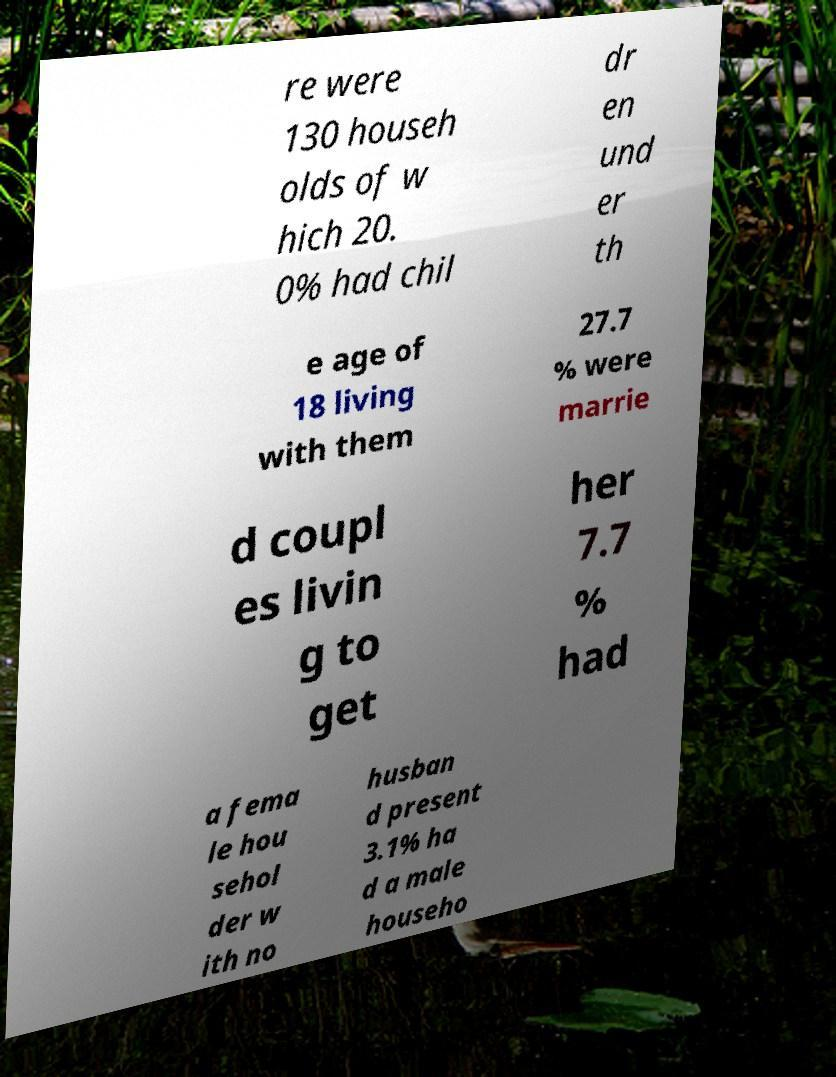Could you assist in decoding the text presented in this image and type it out clearly? re were 130 househ olds of w hich 20. 0% had chil dr en und er th e age of 18 living with them 27.7 % were marrie d coupl es livin g to get her 7.7 % had a fema le hou sehol der w ith no husban d present 3.1% ha d a male househo 